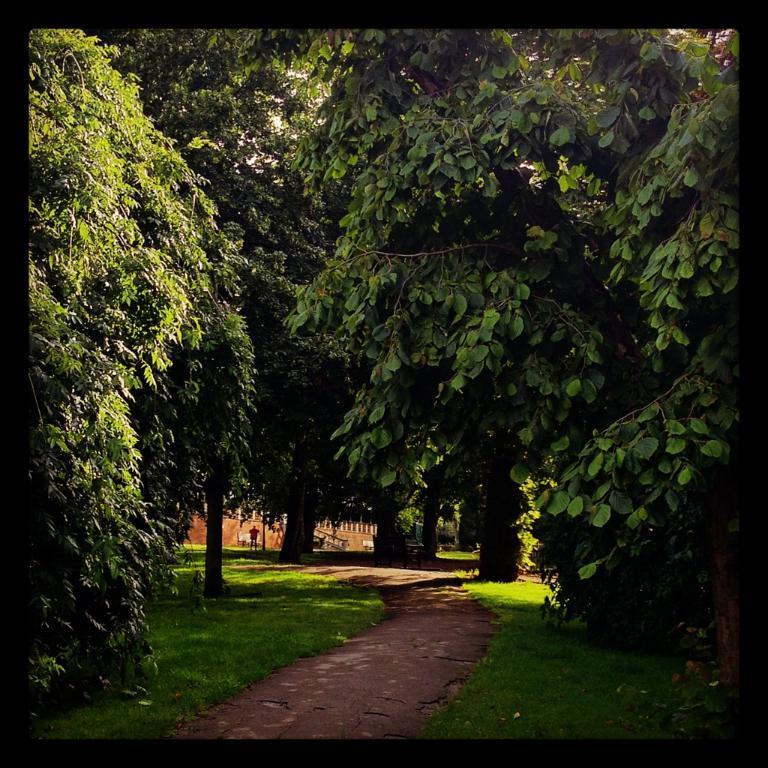Describe this image in one or two sentences. In this picture we can see grass and few trees, in the background we can find a building and a person. 